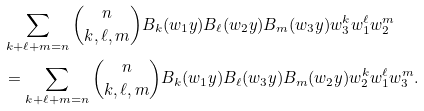<formula> <loc_0><loc_0><loc_500><loc_500>& \sum _ { k + \ell + m = n } \binom { n } { k , \ell , m } B _ { k } ( w _ { 1 } y ) B _ { \ell } ( w _ { 2 } y ) B _ { m } ( w _ { 3 } y ) w _ { 3 } ^ { k } w _ { 1 } ^ { \ell } w _ { 2 } ^ { m } \\ & = \sum _ { k + \ell + m = n } \binom { n } { k , \ell , m } B _ { k } ( w _ { 1 } y ) B _ { \ell } ( w _ { 3 } y ) B _ { m } ( w _ { 2 } y ) w _ { 2 } ^ { k } w _ { 1 } ^ { \ell } w _ { 3 } ^ { m } . \\</formula> 